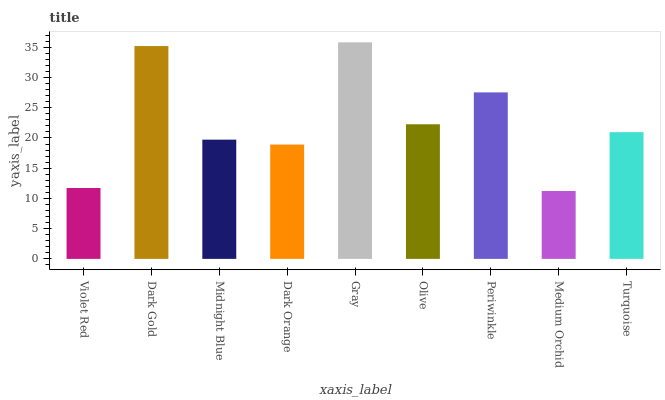Is Medium Orchid the minimum?
Answer yes or no. Yes. Is Gray the maximum?
Answer yes or no. Yes. Is Dark Gold the minimum?
Answer yes or no. No. Is Dark Gold the maximum?
Answer yes or no. No. Is Dark Gold greater than Violet Red?
Answer yes or no. Yes. Is Violet Red less than Dark Gold?
Answer yes or no. Yes. Is Violet Red greater than Dark Gold?
Answer yes or no. No. Is Dark Gold less than Violet Red?
Answer yes or no. No. Is Turquoise the high median?
Answer yes or no. Yes. Is Turquoise the low median?
Answer yes or no. Yes. Is Midnight Blue the high median?
Answer yes or no. No. Is Periwinkle the low median?
Answer yes or no. No. 